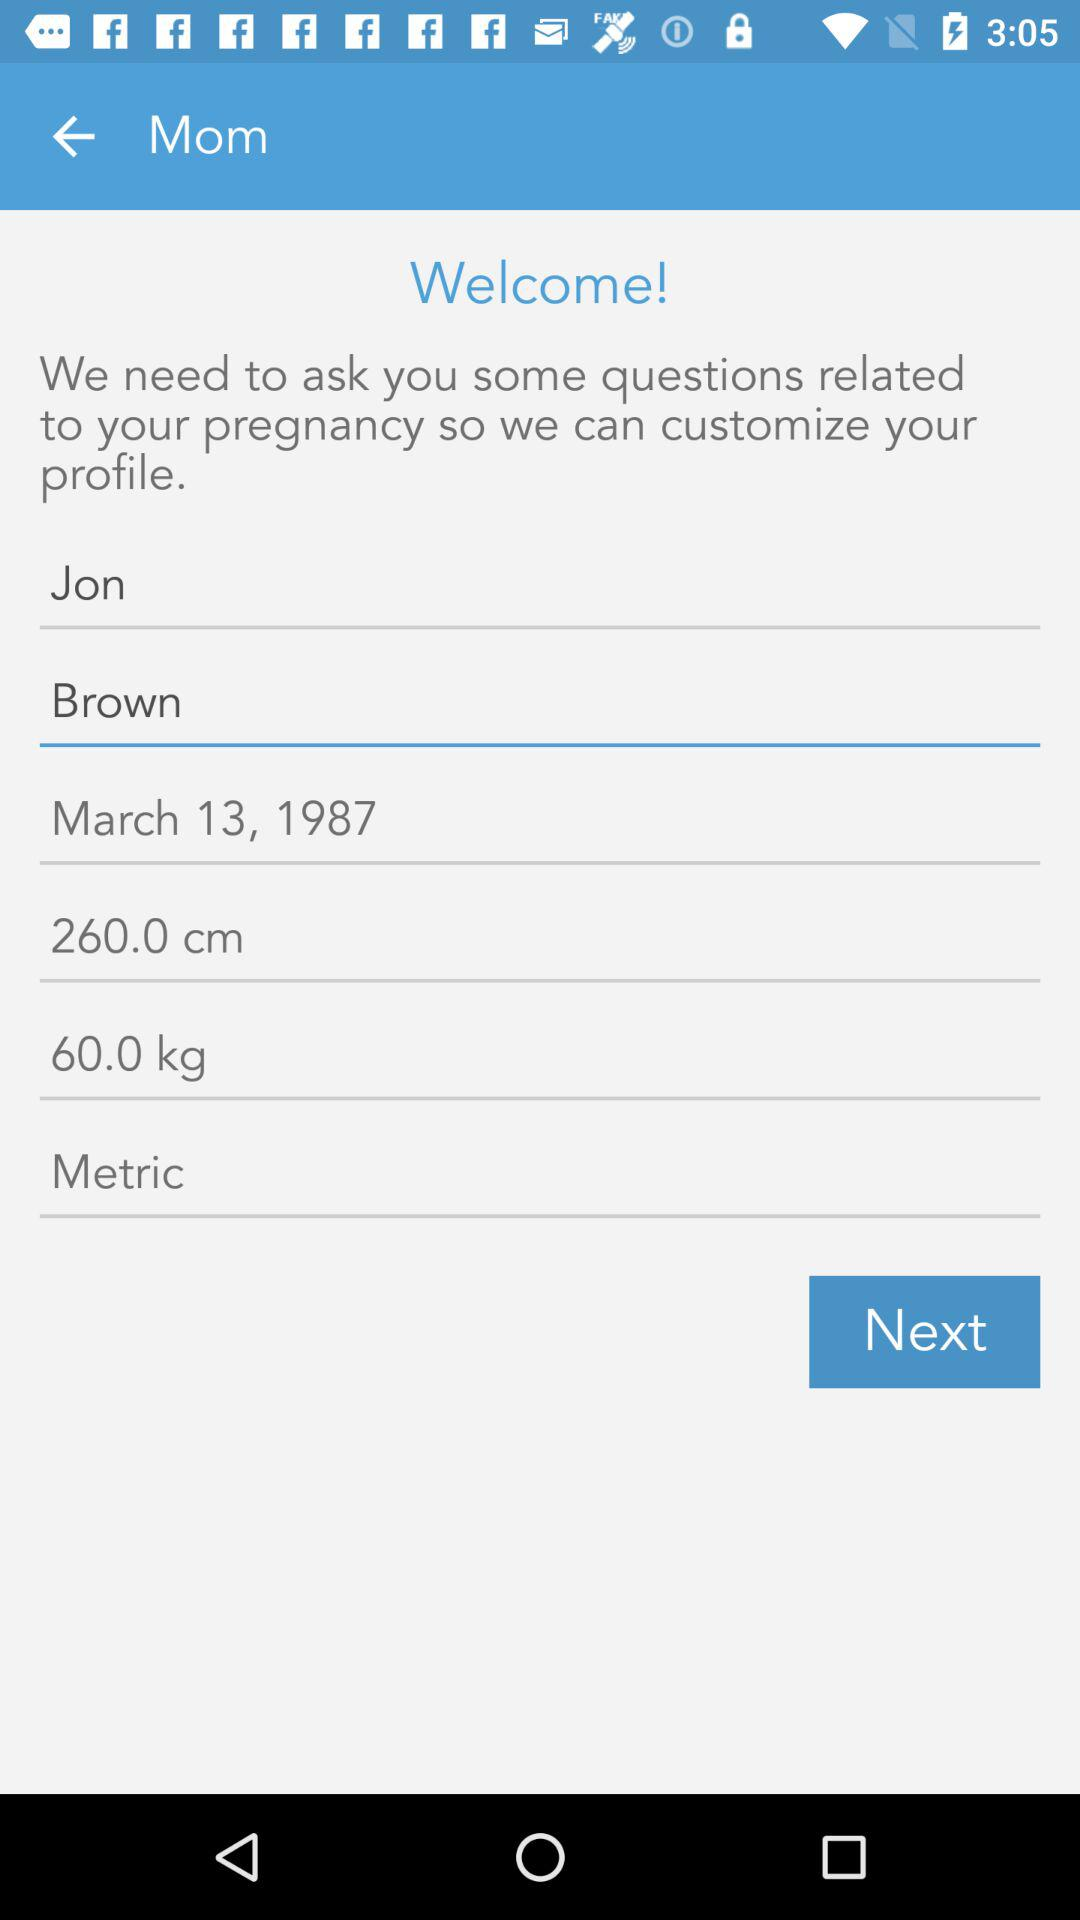How tall is the user? The user is 260.0 cm tall. 